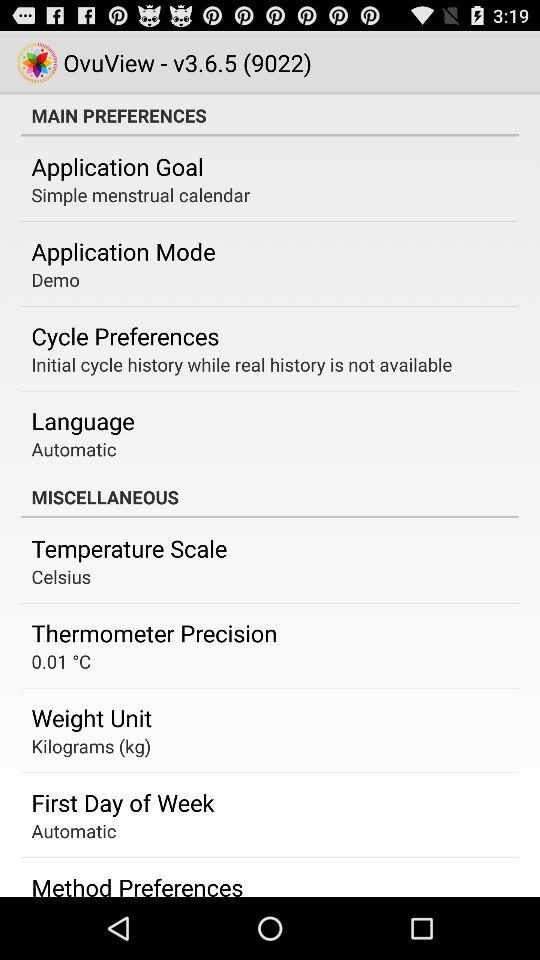What is the app name? The app name is "OvuView". 